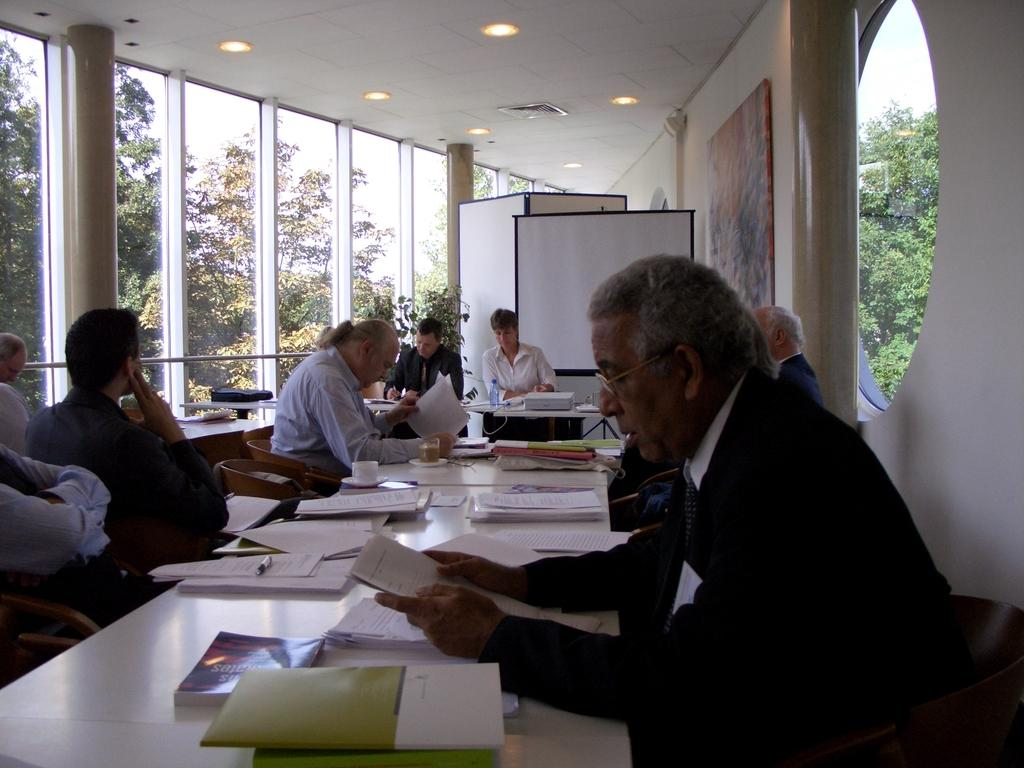What are the people in the image doing? The people in the image are sitting in chairs. Where are the chairs located? The chairs are at tables. What are the people holding in their hands? The people have papers in their hands. What type of lumber is being used to construct the chairs in the image? There is no information about the type of lumber used to construct the chairs in the image. 